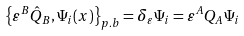Convert formula to latex. <formula><loc_0><loc_0><loc_500><loc_500>\left \{ \varepsilon ^ { B } \hat { Q } _ { B } , \Psi _ { i } ( x ) \right \} _ { p . b } = \delta _ { \varepsilon } \Psi _ { i } = \varepsilon ^ { A } Q _ { A } \Psi _ { i }</formula> 